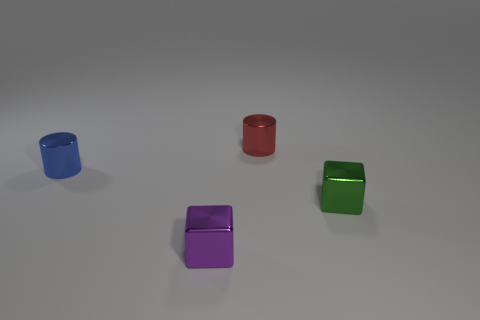Add 4 small red cylinders. How many objects exist? 8 Subtract 1 green blocks. How many objects are left? 3 Subtract all small purple rubber cylinders. Subtract all tiny objects. How many objects are left? 0 Add 2 tiny purple objects. How many tiny purple objects are left? 3 Add 1 red cylinders. How many red cylinders exist? 2 